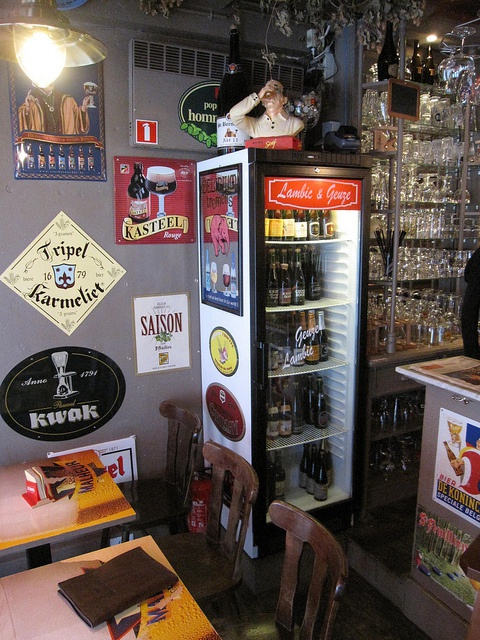Describe the objects in this image and their specific colors. I can see refrigerator in gray, black, lavender, and darkgray tones, bottle in gray, black, and lightgray tones, dining table in gray, lightpink, brown, and black tones, chair in gray, black, and maroon tones, and chair in gray, black, maroon, and brown tones in this image. 